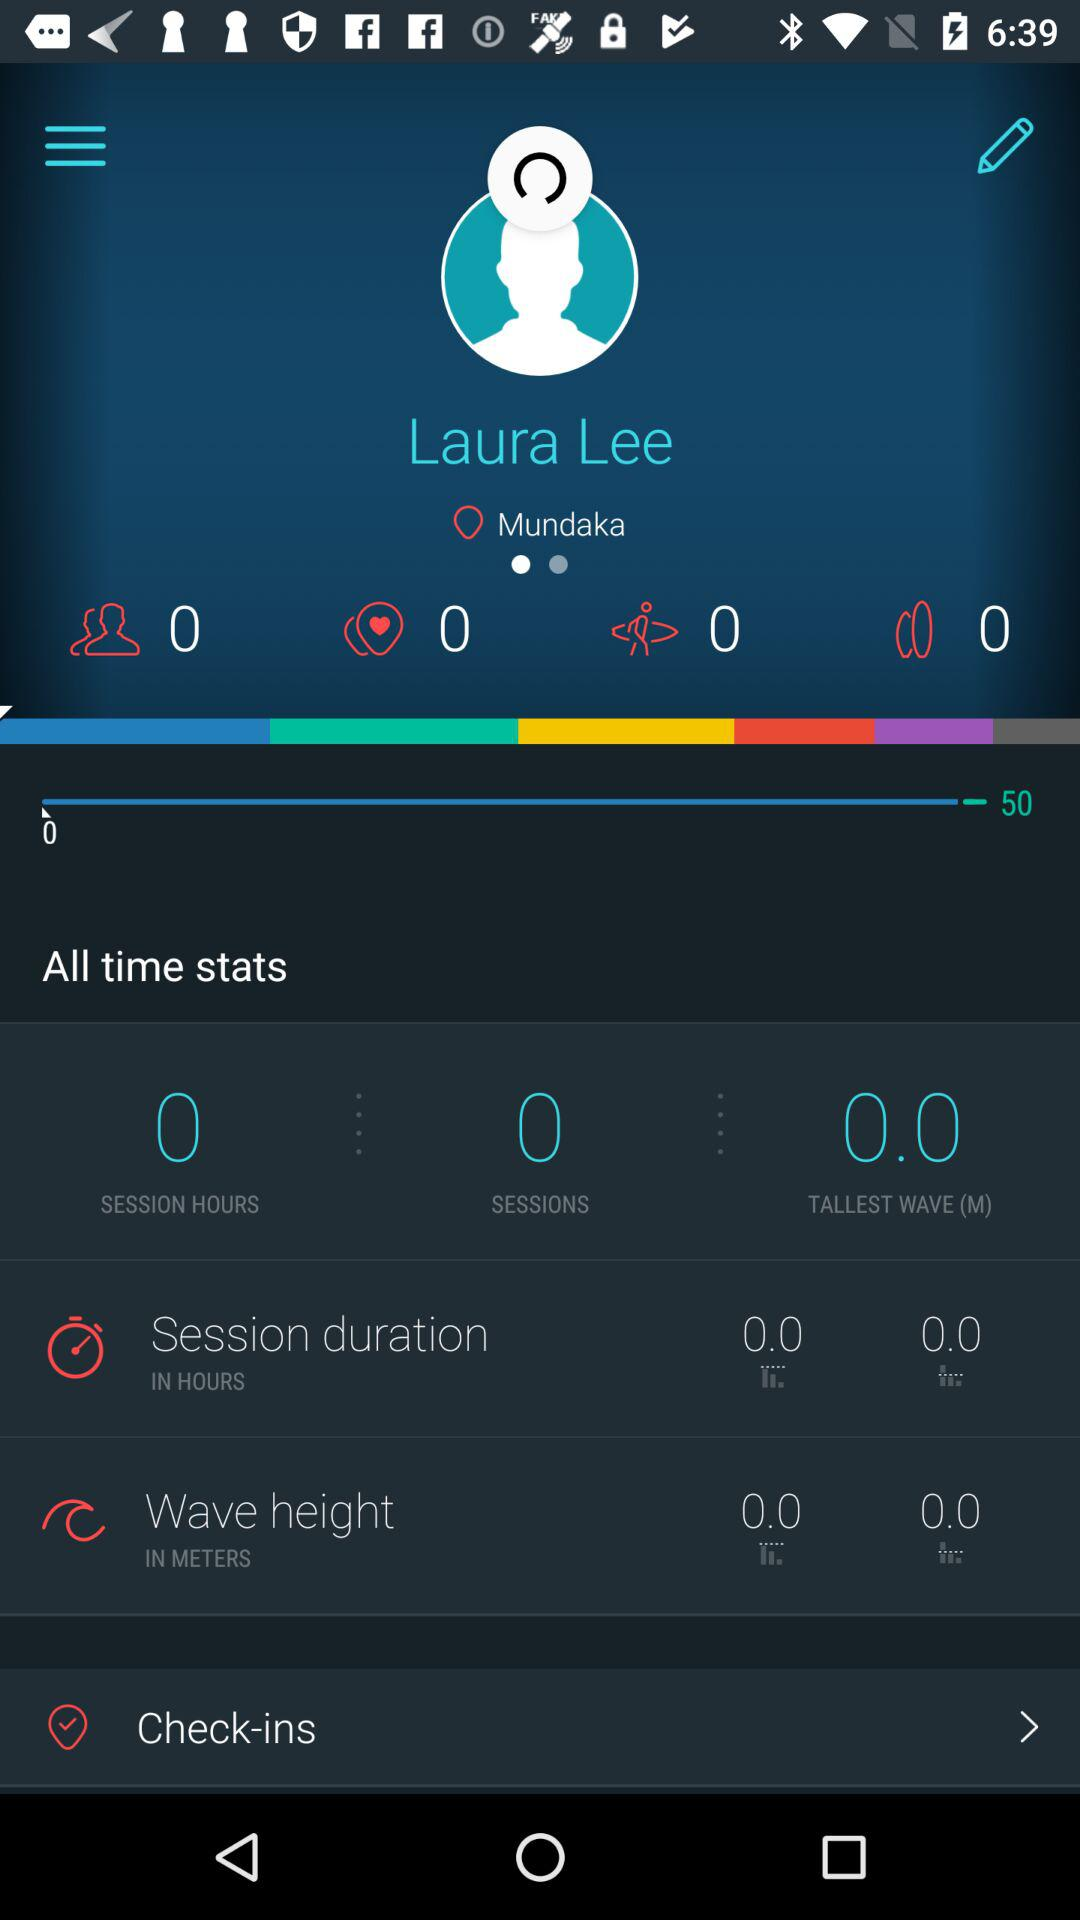What is the tallest wave? The tallest wave is 0 meters. 